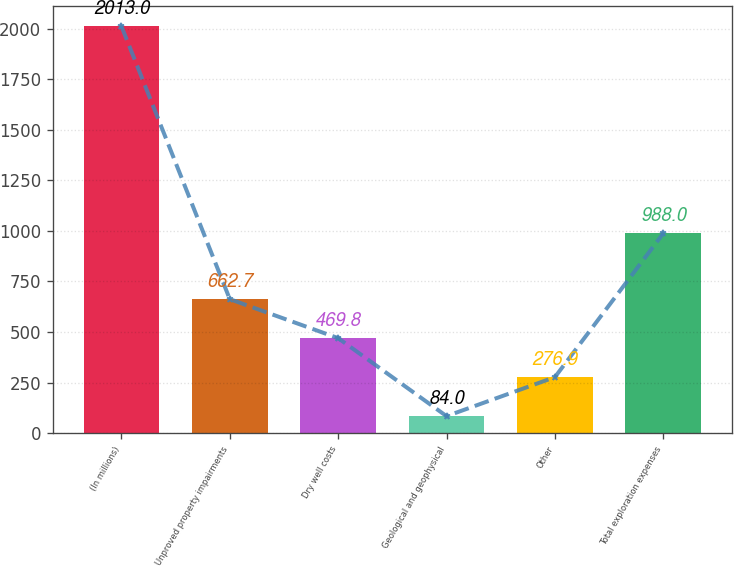<chart> <loc_0><loc_0><loc_500><loc_500><bar_chart><fcel>(In millions)<fcel>Unproved property impairments<fcel>Dry well costs<fcel>Geological and geophysical<fcel>Other<fcel>Total exploration expenses<nl><fcel>2013<fcel>662.7<fcel>469.8<fcel>84<fcel>276.9<fcel>988<nl></chart> 